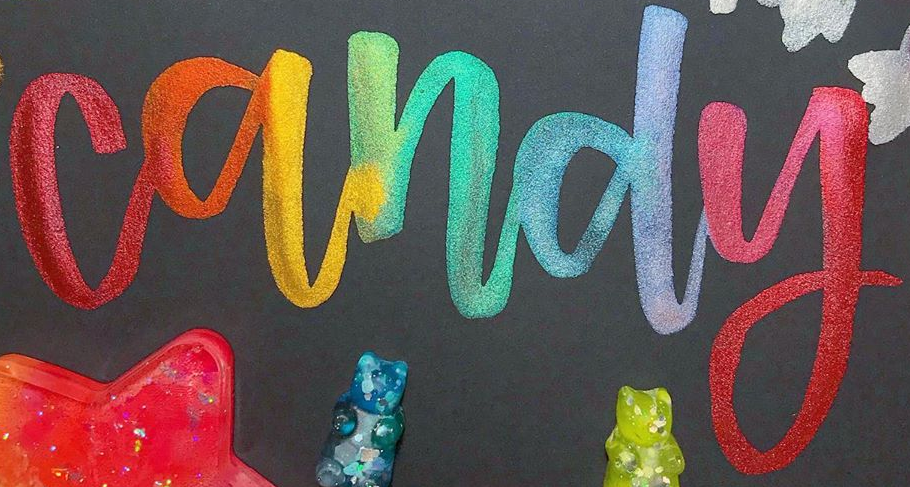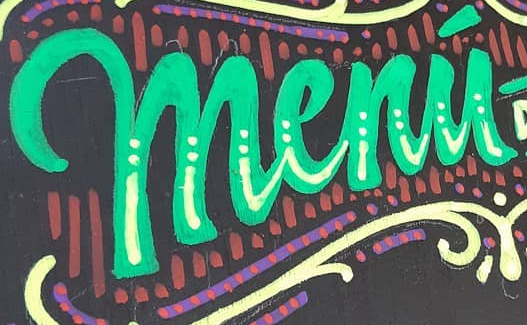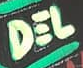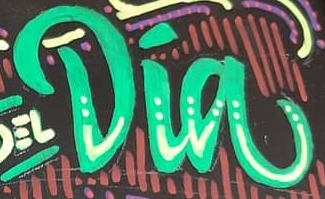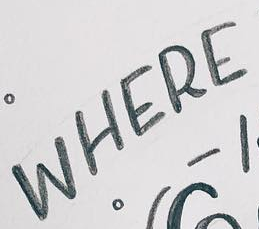What words are shown in these images in order, separated by a semicolon? candy; menú; DEL; Dia; WHERE 